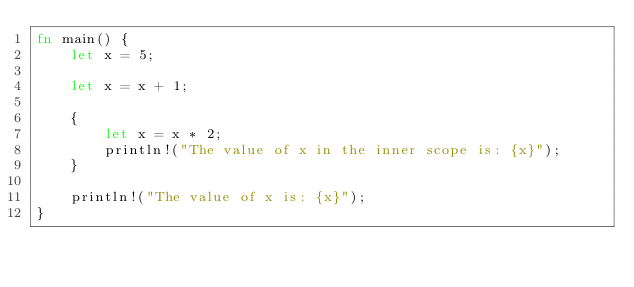<code> <loc_0><loc_0><loc_500><loc_500><_Rust_>fn main() {
    let x = 5;

    let x = x + 1;

    {
        let x = x * 2;
        println!("The value of x in the inner scope is: {x}");
    }

    println!("The value of x is: {x}");
}
</code> 